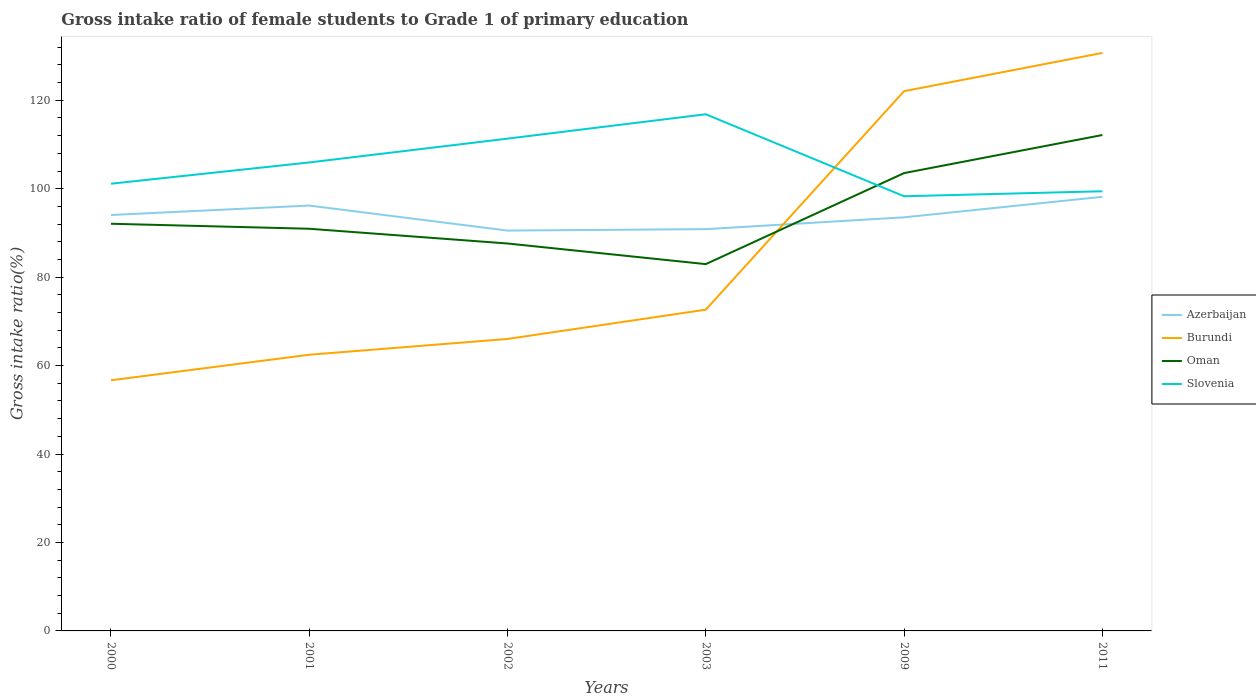Is the number of lines equal to the number of legend labels?
Keep it short and to the point. Yes. Across all years, what is the maximum gross intake ratio in Oman?
Give a very brief answer. 82.95. In which year was the gross intake ratio in Azerbaijan maximum?
Your response must be concise. 2002. What is the total gross intake ratio in Burundi in the graph?
Provide a short and direct response. -49.42. What is the difference between the highest and the second highest gross intake ratio in Oman?
Keep it short and to the point. 29.19. How many lines are there?
Your response must be concise. 4. How many years are there in the graph?
Provide a succinct answer. 6. What is the difference between two consecutive major ticks on the Y-axis?
Your response must be concise. 20. Does the graph contain any zero values?
Make the answer very short. No. How many legend labels are there?
Provide a succinct answer. 4. How are the legend labels stacked?
Your response must be concise. Vertical. What is the title of the graph?
Make the answer very short. Gross intake ratio of female students to Grade 1 of primary education. What is the label or title of the Y-axis?
Keep it short and to the point. Gross intake ratio(%). What is the Gross intake ratio(%) of Azerbaijan in 2000?
Your answer should be compact. 94.05. What is the Gross intake ratio(%) in Burundi in 2000?
Make the answer very short. 56.68. What is the Gross intake ratio(%) in Oman in 2000?
Your answer should be very brief. 92.08. What is the Gross intake ratio(%) in Slovenia in 2000?
Keep it short and to the point. 101.13. What is the Gross intake ratio(%) in Azerbaijan in 2001?
Give a very brief answer. 96.19. What is the Gross intake ratio(%) of Burundi in 2001?
Provide a succinct answer. 62.46. What is the Gross intake ratio(%) in Oman in 2001?
Give a very brief answer. 90.95. What is the Gross intake ratio(%) in Slovenia in 2001?
Keep it short and to the point. 105.94. What is the Gross intake ratio(%) of Azerbaijan in 2002?
Keep it short and to the point. 90.53. What is the Gross intake ratio(%) of Burundi in 2002?
Your answer should be compact. 66.03. What is the Gross intake ratio(%) in Oman in 2002?
Offer a terse response. 87.61. What is the Gross intake ratio(%) in Slovenia in 2002?
Provide a short and direct response. 111.33. What is the Gross intake ratio(%) of Azerbaijan in 2003?
Provide a succinct answer. 90.86. What is the Gross intake ratio(%) in Burundi in 2003?
Keep it short and to the point. 72.65. What is the Gross intake ratio(%) of Oman in 2003?
Offer a terse response. 82.95. What is the Gross intake ratio(%) of Slovenia in 2003?
Give a very brief answer. 116.84. What is the Gross intake ratio(%) in Azerbaijan in 2009?
Give a very brief answer. 93.53. What is the Gross intake ratio(%) of Burundi in 2009?
Make the answer very short. 122.06. What is the Gross intake ratio(%) in Oman in 2009?
Offer a terse response. 103.53. What is the Gross intake ratio(%) in Slovenia in 2009?
Your response must be concise. 98.3. What is the Gross intake ratio(%) of Azerbaijan in 2011?
Make the answer very short. 98.17. What is the Gross intake ratio(%) in Burundi in 2011?
Your response must be concise. 130.71. What is the Gross intake ratio(%) in Oman in 2011?
Provide a short and direct response. 112.14. What is the Gross intake ratio(%) of Slovenia in 2011?
Offer a very short reply. 99.43. Across all years, what is the maximum Gross intake ratio(%) in Azerbaijan?
Your response must be concise. 98.17. Across all years, what is the maximum Gross intake ratio(%) of Burundi?
Provide a succinct answer. 130.71. Across all years, what is the maximum Gross intake ratio(%) in Oman?
Your answer should be compact. 112.14. Across all years, what is the maximum Gross intake ratio(%) in Slovenia?
Provide a succinct answer. 116.84. Across all years, what is the minimum Gross intake ratio(%) of Azerbaijan?
Your answer should be very brief. 90.53. Across all years, what is the minimum Gross intake ratio(%) in Burundi?
Keep it short and to the point. 56.68. Across all years, what is the minimum Gross intake ratio(%) in Oman?
Provide a succinct answer. 82.95. Across all years, what is the minimum Gross intake ratio(%) of Slovenia?
Keep it short and to the point. 98.3. What is the total Gross intake ratio(%) of Azerbaijan in the graph?
Your answer should be compact. 563.34. What is the total Gross intake ratio(%) in Burundi in the graph?
Give a very brief answer. 510.57. What is the total Gross intake ratio(%) of Oman in the graph?
Make the answer very short. 569.26. What is the total Gross intake ratio(%) of Slovenia in the graph?
Make the answer very short. 632.96. What is the difference between the Gross intake ratio(%) of Azerbaijan in 2000 and that in 2001?
Provide a short and direct response. -2.14. What is the difference between the Gross intake ratio(%) in Burundi in 2000 and that in 2001?
Give a very brief answer. -5.77. What is the difference between the Gross intake ratio(%) of Oman in 2000 and that in 2001?
Give a very brief answer. 1.13. What is the difference between the Gross intake ratio(%) of Slovenia in 2000 and that in 2001?
Offer a terse response. -4.81. What is the difference between the Gross intake ratio(%) of Azerbaijan in 2000 and that in 2002?
Provide a succinct answer. 3.52. What is the difference between the Gross intake ratio(%) in Burundi in 2000 and that in 2002?
Make the answer very short. -9.34. What is the difference between the Gross intake ratio(%) in Oman in 2000 and that in 2002?
Your answer should be compact. 4.46. What is the difference between the Gross intake ratio(%) of Slovenia in 2000 and that in 2002?
Offer a terse response. -10.19. What is the difference between the Gross intake ratio(%) of Azerbaijan in 2000 and that in 2003?
Provide a succinct answer. 3.19. What is the difference between the Gross intake ratio(%) of Burundi in 2000 and that in 2003?
Ensure brevity in your answer.  -15.96. What is the difference between the Gross intake ratio(%) of Oman in 2000 and that in 2003?
Your answer should be very brief. 9.13. What is the difference between the Gross intake ratio(%) of Slovenia in 2000 and that in 2003?
Your response must be concise. -15.7. What is the difference between the Gross intake ratio(%) of Azerbaijan in 2000 and that in 2009?
Your answer should be very brief. 0.52. What is the difference between the Gross intake ratio(%) of Burundi in 2000 and that in 2009?
Keep it short and to the point. -65.38. What is the difference between the Gross intake ratio(%) of Oman in 2000 and that in 2009?
Provide a succinct answer. -11.45. What is the difference between the Gross intake ratio(%) of Slovenia in 2000 and that in 2009?
Offer a very short reply. 2.84. What is the difference between the Gross intake ratio(%) in Azerbaijan in 2000 and that in 2011?
Make the answer very short. -4.12. What is the difference between the Gross intake ratio(%) in Burundi in 2000 and that in 2011?
Keep it short and to the point. -74.02. What is the difference between the Gross intake ratio(%) in Oman in 2000 and that in 2011?
Provide a short and direct response. -20.06. What is the difference between the Gross intake ratio(%) in Slovenia in 2000 and that in 2011?
Give a very brief answer. 1.71. What is the difference between the Gross intake ratio(%) of Azerbaijan in 2001 and that in 2002?
Make the answer very short. 5.66. What is the difference between the Gross intake ratio(%) of Burundi in 2001 and that in 2002?
Your response must be concise. -3.57. What is the difference between the Gross intake ratio(%) of Oman in 2001 and that in 2002?
Offer a very short reply. 3.33. What is the difference between the Gross intake ratio(%) in Slovenia in 2001 and that in 2002?
Ensure brevity in your answer.  -5.39. What is the difference between the Gross intake ratio(%) of Azerbaijan in 2001 and that in 2003?
Keep it short and to the point. 5.33. What is the difference between the Gross intake ratio(%) in Burundi in 2001 and that in 2003?
Provide a short and direct response. -10.19. What is the difference between the Gross intake ratio(%) in Oman in 2001 and that in 2003?
Ensure brevity in your answer.  8. What is the difference between the Gross intake ratio(%) in Slovenia in 2001 and that in 2003?
Your response must be concise. -10.9. What is the difference between the Gross intake ratio(%) in Azerbaijan in 2001 and that in 2009?
Give a very brief answer. 2.66. What is the difference between the Gross intake ratio(%) in Burundi in 2001 and that in 2009?
Your answer should be very brief. -59.61. What is the difference between the Gross intake ratio(%) in Oman in 2001 and that in 2009?
Provide a succinct answer. -12.59. What is the difference between the Gross intake ratio(%) in Slovenia in 2001 and that in 2009?
Keep it short and to the point. 7.64. What is the difference between the Gross intake ratio(%) of Azerbaijan in 2001 and that in 2011?
Provide a succinct answer. -1.98. What is the difference between the Gross intake ratio(%) of Burundi in 2001 and that in 2011?
Provide a short and direct response. -68.25. What is the difference between the Gross intake ratio(%) of Oman in 2001 and that in 2011?
Your answer should be very brief. -21.2. What is the difference between the Gross intake ratio(%) in Slovenia in 2001 and that in 2011?
Ensure brevity in your answer.  6.51. What is the difference between the Gross intake ratio(%) in Azerbaijan in 2002 and that in 2003?
Ensure brevity in your answer.  -0.33. What is the difference between the Gross intake ratio(%) in Burundi in 2002 and that in 2003?
Ensure brevity in your answer.  -6.62. What is the difference between the Gross intake ratio(%) in Oman in 2002 and that in 2003?
Ensure brevity in your answer.  4.66. What is the difference between the Gross intake ratio(%) of Slovenia in 2002 and that in 2003?
Your answer should be compact. -5.51. What is the difference between the Gross intake ratio(%) in Azerbaijan in 2002 and that in 2009?
Provide a succinct answer. -3. What is the difference between the Gross intake ratio(%) in Burundi in 2002 and that in 2009?
Make the answer very short. -56.03. What is the difference between the Gross intake ratio(%) of Oman in 2002 and that in 2009?
Give a very brief answer. -15.92. What is the difference between the Gross intake ratio(%) in Slovenia in 2002 and that in 2009?
Keep it short and to the point. 13.03. What is the difference between the Gross intake ratio(%) in Azerbaijan in 2002 and that in 2011?
Make the answer very short. -7.64. What is the difference between the Gross intake ratio(%) in Burundi in 2002 and that in 2011?
Your response must be concise. -64.68. What is the difference between the Gross intake ratio(%) of Oman in 2002 and that in 2011?
Provide a short and direct response. -24.53. What is the difference between the Gross intake ratio(%) of Slovenia in 2002 and that in 2011?
Provide a succinct answer. 11.9. What is the difference between the Gross intake ratio(%) in Azerbaijan in 2003 and that in 2009?
Make the answer very short. -2.67. What is the difference between the Gross intake ratio(%) of Burundi in 2003 and that in 2009?
Offer a terse response. -49.42. What is the difference between the Gross intake ratio(%) in Oman in 2003 and that in 2009?
Make the answer very short. -20.58. What is the difference between the Gross intake ratio(%) of Slovenia in 2003 and that in 2009?
Ensure brevity in your answer.  18.54. What is the difference between the Gross intake ratio(%) in Azerbaijan in 2003 and that in 2011?
Give a very brief answer. -7.31. What is the difference between the Gross intake ratio(%) of Burundi in 2003 and that in 2011?
Your answer should be compact. -58.06. What is the difference between the Gross intake ratio(%) in Oman in 2003 and that in 2011?
Make the answer very short. -29.19. What is the difference between the Gross intake ratio(%) in Slovenia in 2003 and that in 2011?
Make the answer very short. 17.41. What is the difference between the Gross intake ratio(%) in Azerbaijan in 2009 and that in 2011?
Your answer should be compact. -4.64. What is the difference between the Gross intake ratio(%) of Burundi in 2009 and that in 2011?
Ensure brevity in your answer.  -8.64. What is the difference between the Gross intake ratio(%) of Oman in 2009 and that in 2011?
Make the answer very short. -8.61. What is the difference between the Gross intake ratio(%) in Slovenia in 2009 and that in 2011?
Offer a terse response. -1.13. What is the difference between the Gross intake ratio(%) in Azerbaijan in 2000 and the Gross intake ratio(%) in Burundi in 2001?
Your answer should be compact. 31.6. What is the difference between the Gross intake ratio(%) in Azerbaijan in 2000 and the Gross intake ratio(%) in Oman in 2001?
Your response must be concise. 3.11. What is the difference between the Gross intake ratio(%) in Azerbaijan in 2000 and the Gross intake ratio(%) in Slovenia in 2001?
Make the answer very short. -11.89. What is the difference between the Gross intake ratio(%) of Burundi in 2000 and the Gross intake ratio(%) of Oman in 2001?
Make the answer very short. -34.26. What is the difference between the Gross intake ratio(%) of Burundi in 2000 and the Gross intake ratio(%) of Slovenia in 2001?
Make the answer very short. -49.26. What is the difference between the Gross intake ratio(%) of Oman in 2000 and the Gross intake ratio(%) of Slovenia in 2001?
Provide a succinct answer. -13.86. What is the difference between the Gross intake ratio(%) of Azerbaijan in 2000 and the Gross intake ratio(%) of Burundi in 2002?
Provide a short and direct response. 28.03. What is the difference between the Gross intake ratio(%) in Azerbaijan in 2000 and the Gross intake ratio(%) in Oman in 2002?
Ensure brevity in your answer.  6.44. What is the difference between the Gross intake ratio(%) in Azerbaijan in 2000 and the Gross intake ratio(%) in Slovenia in 2002?
Give a very brief answer. -17.27. What is the difference between the Gross intake ratio(%) of Burundi in 2000 and the Gross intake ratio(%) of Oman in 2002?
Provide a succinct answer. -30.93. What is the difference between the Gross intake ratio(%) in Burundi in 2000 and the Gross intake ratio(%) in Slovenia in 2002?
Provide a short and direct response. -54.65. What is the difference between the Gross intake ratio(%) of Oman in 2000 and the Gross intake ratio(%) of Slovenia in 2002?
Keep it short and to the point. -19.25. What is the difference between the Gross intake ratio(%) in Azerbaijan in 2000 and the Gross intake ratio(%) in Burundi in 2003?
Your answer should be compact. 21.41. What is the difference between the Gross intake ratio(%) of Azerbaijan in 2000 and the Gross intake ratio(%) of Oman in 2003?
Provide a short and direct response. 11.1. What is the difference between the Gross intake ratio(%) of Azerbaijan in 2000 and the Gross intake ratio(%) of Slovenia in 2003?
Your answer should be very brief. -22.78. What is the difference between the Gross intake ratio(%) in Burundi in 2000 and the Gross intake ratio(%) in Oman in 2003?
Offer a very short reply. -26.27. What is the difference between the Gross intake ratio(%) in Burundi in 2000 and the Gross intake ratio(%) in Slovenia in 2003?
Your response must be concise. -60.16. What is the difference between the Gross intake ratio(%) in Oman in 2000 and the Gross intake ratio(%) in Slovenia in 2003?
Make the answer very short. -24.76. What is the difference between the Gross intake ratio(%) in Azerbaijan in 2000 and the Gross intake ratio(%) in Burundi in 2009?
Offer a terse response. -28.01. What is the difference between the Gross intake ratio(%) in Azerbaijan in 2000 and the Gross intake ratio(%) in Oman in 2009?
Provide a succinct answer. -9.48. What is the difference between the Gross intake ratio(%) of Azerbaijan in 2000 and the Gross intake ratio(%) of Slovenia in 2009?
Your answer should be compact. -4.24. What is the difference between the Gross intake ratio(%) of Burundi in 2000 and the Gross intake ratio(%) of Oman in 2009?
Keep it short and to the point. -46.85. What is the difference between the Gross intake ratio(%) in Burundi in 2000 and the Gross intake ratio(%) in Slovenia in 2009?
Ensure brevity in your answer.  -41.61. What is the difference between the Gross intake ratio(%) in Oman in 2000 and the Gross intake ratio(%) in Slovenia in 2009?
Keep it short and to the point. -6.22. What is the difference between the Gross intake ratio(%) in Azerbaijan in 2000 and the Gross intake ratio(%) in Burundi in 2011?
Your response must be concise. -36.65. What is the difference between the Gross intake ratio(%) in Azerbaijan in 2000 and the Gross intake ratio(%) in Oman in 2011?
Offer a terse response. -18.09. What is the difference between the Gross intake ratio(%) of Azerbaijan in 2000 and the Gross intake ratio(%) of Slovenia in 2011?
Keep it short and to the point. -5.37. What is the difference between the Gross intake ratio(%) of Burundi in 2000 and the Gross intake ratio(%) of Oman in 2011?
Provide a short and direct response. -55.46. What is the difference between the Gross intake ratio(%) of Burundi in 2000 and the Gross intake ratio(%) of Slovenia in 2011?
Keep it short and to the point. -42.74. What is the difference between the Gross intake ratio(%) of Oman in 2000 and the Gross intake ratio(%) of Slovenia in 2011?
Your answer should be very brief. -7.35. What is the difference between the Gross intake ratio(%) of Azerbaijan in 2001 and the Gross intake ratio(%) of Burundi in 2002?
Your answer should be compact. 30.17. What is the difference between the Gross intake ratio(%) in Azerbaijan in 2001 and the Gross intake ratio(%) in Oman in 2002?
Offer a very short reply. 8.58. What is the difference between the Gross intake ratio(%) in Azerbaijan in 2001 and the Gross intake ratio(%) in Slovenia in 2002?
Ensure brevity in your answer.  -15.13. What is the difference between the Gross intake ratio(%) in Burundi in 2001 and the Gross intake ratio(%) in Oman in 2002?
Offer a terse response. -25.16. What is the difference between the Gross intake ratio(%) in Burundi in 2001 and the Gross intake ratio(%) in Slovenia in 2002?
Your response must be concise. -48.87. What is the difference between the Gross intake ratio(%) in Oman in 2001 and the Gross intake ratio(%) in Slovenia in 2002?
Your answer should be compact. -20.38. What is the difference between the Gross intake ratio(%) of Azerbaijan in 2001 and the Gross intake ratio(%) of Burundi in 2003?
Offer a terse response. 23.55. What is the difference between the Gross intake ratio(%) of Azerbaijan in 2001 and the Gross intake ratio(%) of Oman in 2003?
Offer a very short reply. 13.24. What is the difference between the Gross intake ratio(%) of Azerbaijan in 2001 and the Gross intake ratio(%) of Slovenia in 2003?
Give a very brief answer. -20.64. What is the difference between the Gross intake ratio(%) in Burundi in 2001 and the Gross intake ratio(%) in Oman in 2003?
Offer a very short reply. -20.5. What is the difference between the Gross intake ratio(%) of Burundi in 2001 and the Gross intake ratio(%) of Slovenia in 2003?
Ensure brevity in your answer.  -54.38. What is the difference between the Gross intake ratio(%) of Oman in 2001 and the Gross intake ratio(%) of Slovenia in 2003?
Provide a short and direct response. -25.89. What is the difference between the Gross intake ratio(%) in Azerbaijan in 2001 and the Gross intake ratio(%) in Burundi in 2009?
Your response must be concise. -25.87. What is the difference between the Gross intake ratio(%) of Azerbaijan in 2001 and the Gross intake ratio(%) of Oman in 2009?
Your response must be concise. -7.34. What is the difference between the Gross intake ratio(%) in Azerbaijan in 2001 and the Gross intake ratio(%) in Slovenia in 2009?
Offer a terse response. -2.1. What is the difference between the Gross intake ratio(%) of Burundi in 2001 and the Gross intake ratio(%) of Oman in 2009?
Offer a terse response. -41.08. What is the difference between the Gross intake ratio(%) of Burundi in 2001 and the Gross intake ratio(%) of Slovenia in 2009?
Provide a short and direct response. -35.84. What is the difference between the Gross intake ratio(%) of Oman in 2001 and the Gross intake ratio(%) of Slovenia in 2009?
Make the answer very short. -7.35. What is the difference between the Gross intake ratio(%) in Azerbaijan in 2001 and the Gross intake ratio(%) in Burundi in 2011?
Provide a short and direct response. -34.51. What is the difference between the Gross intake ratio(%) in Azerbaijan in 2001 and the Gross intake ratio(%) in Oman in 2011?
Your answer should be compact. -15.95. What is the difference between the Gross intake ratio(%) in Azerbaijan in 2001 and the Gross intake ratio(%) in Slovenia in 2011?
Offer a terse response. -3.23. What is the difference between the Gross intake ratio(%) in Burundi in 2001 and the Gross intake ratio(%) in Oman in 2011?
Your response must be concise. -49.69. What is the difference between the Gross intake ratio(%) of Burundi in 2001 and the Gross intake ratio(%) of Slovenia in 2011?
Your response must be concise. -36.97. What is the difference between the Gross intake ratio(%) of Oman in 2001 and the Gross intake ratio(%) of Slovenia in 2011?
Offer a terse response. -8.48. What is the difference between the Gross intake ratio(%) of Azerbaijan in 2002 and the Gross intake ratio(%) of Burundi in 2003?
Make the answer very short. 17.89. What is the difference between the Gross intake ratio(%) of Azerbaijan in 2002 and the Gross intake ratio(%) of Oman in 2003?
Your answer should be very brief. 7.58. What is the difference between the Gross intake ratio(%) of Azerbaijan in 2002 and the Gross intake ratio(%) of Slovenia in 2003?
Keep it short and to the point. -26.3. What is the difference between the Gross intake ratio(%) of Burundi in 2002 and the Gross intake ratio(%) of Oman in 2003?
Provide a short and direct response. -16.92. What is the difference between the Gross intake ratio(%) of Burundi in 2002 and the Gross intake ratio(%) of Slovenia in 2003?
Offer a terse response. -50.81. What is the difference between the Gross intake ratio(%) in Oman in 2002 and the Gross intake ratio(%) in Slovenia in 2003?
Keep it short and to the point. -29.22. What is the difference between the Gross intake ratio(%) of Azerbaijan in 2002 and the Gross intake ratio(%) of Burundi in 2009?
Offer a terse response. -31.53. What is the difference between the Gross intake ratio(%) of Azerbaijan in 2002 and the Gross intake ratio(%) of Oman in 2009?
Provide a succinct answer. -13. What is the difference between the Gross intake ratio(%) of Azerbaijan in 2002 and the Gross intake ratio(%) of Slovenia in 2009?
Make the answer very short. -7.76. What is the difference between the Gross intake ratio(%) of Burundi in 2002 and the Gross intake ratio(%) of Oman in 2009?
Give a very brief answer. -37.51. What is the difference between the Gross intake ratio(%) of Burundi in 2002 and the Gross intake ratio(%) of Slovenia in 2009?
Give a very brief answer. -32.27. What is the difference between the Gross intake ratio(%) of Oman in 2002 and the Gross intake ratio(%) of Slovenia in 2009?
Your response must be concise. -10.68. What is the difference between the Gross intake ratio(%) in Azerbaijan in 2002 and the Gross intake ratio(%) in Burundi in 2011?
Offer a very short reply. -40.17. What is the difference between the Gross intake ratio(%) of Azerbaijan in 2002 and the Gross intake ratio(%) of Oman in 2011?
Give a very brief answer. -21.61. What is the difference between the Gross intake ratio(%) of Azerbaijan in 2002 and the Gross intake ratio(%) of Slovenia in 2011?
Make the answer very short. -8.89. What is the difference between the Gross intake ratio(%) in Burundi in 2002 and the Gross intake ratio(%) in Oman in 2011?
Make the answer very short. -46.12. What is the difference between the Gross intake ratio(%) of Burundi in 2002 and the Gross intake ratio(%) of Slovenia in 2011?
Make the answer very short. -33.4. What is the difference between the Gross intake ratio(%) in Oman in 2002 and the Gross intake ratio(%) in Slovenia in 2011?
Your answer should be compact. -11.81. What is the difference between the Gross intake ratio(%) in Azerbaijan in 2003 and the Gross intake ratio(%) in Burundi in 2009?
Provide a succinct answer. -31.2. What is the difference between the Gross intake ratio(%) of Azerbaijan in 2003 and the Gross intake ratio(%) of Oman in 2009?
Offer a very short reply. -12.67. What is the difference between the Gross intake ratio(%) in Azerbaijan in 2003 and the Gross intake ratio(%) in Slovenia in 2009?
Offer a very short reply. -7.44. What is the difference between the Gross intake ratio(%) in Burundi in 2003 and the Gross intake ratio(%) in Oman in 2009?
Provide a short and direct response. -30.89. What is the difference between the Gross intake ratio(%) in Burundi in 2003 and the Gross intake ratio(%) in Slovenia in 2009?
Keep it short and to the point. -25.65. What is the difference between the Gross intake ratio(%) of Oman in 2003 and the Gross intake ratio(%) of Slovenia in 2009?
Your response must be concise. -15.35. What is the difference between the Gross intake ratio(%) of Azerbaijan in 2003 and the Gross intake ratio(%) of Burundi in 2011?
Your answer should be compact. -39.85. What is the difference between the Gross intake ratio(%) in Azerbaijan in 2003 and the Gross intake ratio(%) in Oman in 2011?
Offer a terse response. -21.28. What is the difference between the Gross intake ratio(%) in Azerbaijan in 2003 and the Gross intake ratio(%) in Slovenia in 2011?
Offer a very short reply. -8.57. What is the difference between the Gross intake ratio(%) of Burundi in 2003 and the Gross intake ratio(%) of Oman in 2011?
Provide a succinct answer. -39.5. What is the difference between the Gross intake ratio(%) in Burundi in 2003 and the Gross intake ratio(%) in Slovenia in 2011?
Offer a terse response. -26.78. What is the difference between the Gross intake ratio(%) in Oman in 2003 and the Gross intake ratio(%) in Slovenia in 2011?
Your answer should be compact. -16.47. What is the difference between the Gross intake ratio(%) in Azerbaijan in 2009 and the Gross intake ratio(%) in Burundi in 2011?
Your answer should be very brief. -37.18. What is the difference between the Gross intake ratio(%) of Azerbaijan in 2009 and the Gross intake ratio(%) of Oman in 2011?
Provide a succinct answer. -18.61. What is the difference between the Gross intake ratio(%) in Azerbaijan in 2009 and the Gross intake ratio(%) in Slovenia in 2011?
Make the answer very short. -5.9. What is the difference between the Gross intake ratio(%) in Burundi in 2009 and the Gross intake ratio(%) in Oman in 2011?
Your answer should be compact. 9.92. What is the difference between the Gross intake ratio(%) in Burundi in 2009 and the Gross intake ratio(%) in Slovenia in 2011?
Offer a very short reply. 22.64. What is the difference between the Gross intake ratio(%) in Oman in 2009 and the Gross intake ratio(%) in Slovenia in 2011?
Your response must be concise. 4.11. What is the average Gross intake ratio(%) in Azerbaijan per year?
Your answer should be very brief. 93.89. What is the average Gross intake ratio(%) of Burundi per year?
Offer a very short reply. 85.1. What is the average Gross intake ratio(%) of Oman per year?
Offer a very short reply. 94.88. What is the average Gross intake ratio(%) in Slovenia per year?
Provide a short and direct response. 105.49. In the year 2000, what is the difference between the Gross intake ratio(%) in Azerbaijan and Gross intake ratio(%) in Burundi?
Keep it short and to the point. 37.37. In the year 2000, what is the difference between the Gross intake ratio(%) of Azerbaijan and Gross intake ratio(%) of Oman?
Make the answer very short. 1.98. In the year 2000, what is the difference between the Gross intake ratio(%) of Azerbaijan and Gross intake ratio(%) of Slovenia?
Make the answer very short. -7.08. In the year 2000, what is the difference between the Gross intake ratio(%) of Burundi and Gross intake ratio(%) of Oman?
Your answer should be compact. -35.4. In the year 2000, what is the difference between the Gross intake ratio(%) of Burundi and Gross intake ratio(%) of Slovenia?
Your answer should be compact. -44.45. In the year 2000, what is the difference between the Gross intake ratio(%) in Oman and Gross intake ratio(%) in Slovenia?
Your response must be concise. -9.05. In the year 2001, what is the difference between the Gross intake ratio(%) of Azerbaijan and Gross intake ratio(%) of Burundi?
Keep it short and to the point. 33.74. In the year 2001, what is the difference between the Gross intake ratio(%) in Azerbaijan and Gross intake ratio(%) in Oman?
Make the answer very short. 5.25. In the year 2001, what is the difference between the Gross intake ratio(%) of Azerbaijan and Gross intake ratio(%) of Slovenia?
Keep it short and to the point. -9.75. In the year 2001, what is the difference between the Gross intake ratio(%) in Burundi and Gross intake ratio(%) in Oman?
Offer a very short reply. -28.49. In the year 2001, what is the difference between the Gross intake ratio(%) in Burundi and Gross intake ratio(%) in Slovenia?
Give a very brief answer. -43.48. In the year 2001, what is the difference between the Gross intake ratio(%) in Oman and Gross intake ratio(%) in Slovenia?
Your answer should be compact. -14.99. In the year 2002, what is the difference between the Gross intake ratio(%) of Azerbaijan and Gross intake ratio(%) of Burundi?
Offer a terse response. 24.51. In the year 2002, what is the difference between the Gross intake ratio(%) of Azerbaijan and Gross intake ratio(%) of Oman?
Give a very brief answer. 2.92. In the year 2002, what is the difference between the Gross intake ratio(%) of Azerbaijan and Gross intake ratio(%) of Slovenia?
Give a very brief answer. -20.79. In the year 2002, what is the difference between the Gross intake ratio(%) of Burundi and Gross intake ratio(%) of Oman?
Your answer should be very brief. -21.59. In the year 2002, what is the difference between the Gross intake ratio(%) of Burundi and Gross intake ratio(%) of Slovenia?
Ensure brevity in your answer.  -45.3. In the year 2002, what is the difference between the Gross intake ratio(%) of Oman and Gross intake ratio(%) of Slovenia?
Your response must be concise. -23.71. In the year 2003, what is the difference between the Gross intake ratio(%) of Azerbaijan and Gross intake ratio(%) of Burundi?
Offer a terse response. 18.21. In the year 2003, what is the difference between the Gross intake ratio(%) of Azerbaijan and Gross intake ratio(%) of Oman?
Offer a terse response. 7.91. In the year 2003, what is the difference between the Gross intake ratio(%) of Azerbaijan and Gross intake ratio(%) of Slovenia?
Your answer should be compact. -25.98. In the year 2003, what is the difference between the Gross intake ratio(%) of Burundi and Gross intake ratio(%) of Oman?
Your answer should be compact. -10.31. In the year 2003, what is the difference between the Gross intake ratio(%) in Burundi and Gross intake ratio(%) in Slovenia?
Your answer should be very brief. -44.19. In the year 2003, what is the difference between the Gross intake ratio(%) of Oman and Gross intake ratio(%) of Slovenia?
Give a very brief answer. -33.89. In the year 2009, what is the difference between the Gross intake ratio(%) of Azerbaijan and Gross intake ratio(%) of Burundi?
Offer a terse response. -28.53. In the year 2009, what is the difference between the Gross intake ratio(%) in Azerbaijan and Gross intake ratio(%) in Oman?
Make the answer very short. -10. In the year 2009, what is the difference between the Gross intake ratio(%) of Azerbaijan and Gross intake ratio(%) of Slovenia?
Give a very brief answer. -4.77. In the year 2009, what is the difference between the Gross intake ratio(%) in Burundi and Gross intake ratio(%) in Oman?
Offer a terse response. 18.53. In the year 2009, what is the difference between the Gross intake ratio(%) of Burundi and Gross intake ratio(%) of Slovenia?
Provide a short and direct response. 23.76. In the year 2009, what is the difference between the Gross intake ratio(%) of Oman and Gross intake ratio(%) of Slovenia?
Your answer should be very brief. 5.24. In the year 2011, what is the difference between the Gross intake ratio(%) in Azerbaijan and Gross intake ratio(%) in Burundi?
Give a very brief answer. -32.53. In the year 2011, what is the difference between the Gross intake ratio(%) of Azerbaijan and Gross intake ratio(%) of Oman?
Keep it short and to the point. -13.97. In the year 2011, what is the difference between the Gross intake ratio(%) of Azerbaijan and Gross intake ratio(%) of Slovenia?
Ensure brevity in your answer.  -1.25. In the year 2011, what is the difference between the Gross intake ratio(%) of Burundi and Gross intake ratio(%) of Oman?
Your answer should be compact. 18.56. In the year 2011, what is the difference between the Gross intake ratio(%) in Burundi and Gross intake ratio(%) in Slovenia?
Give a very brief answer. 31.28. In the year 2011, what is the difference between the Gross intake ratio(%) in Oman and Gross intake ratio(%) in Slovenia?
Your answer should be very brief. 12.72. What is the ratio of the Gross intake ratio(%) of Azerbaijan in 2000 to that in 2001?
Your answer should be compact. 0.98. What is the ratio of the Gross intake ratio(%) of Burundi in 2000 to that in 2001?
Make the answer very short. 0.91. What is the ratio of the Gross intake ratio(%) of Oman in 2000 to that in 2001?
Ensure brevity in your answer.  1.01. What is the ratio of the Gross intake ratio(%) in Slovenia in 2000 to that in 2001?
Your answer should be very brief. 0.95. What is the ratio of the Gross intake ratio(%) in Azerbaijan in 2000 to that in 2002?
Offer a very short reply. 1.04. What is the ratio of the Gross intake ratio(%) of Burundi in 2000 to that in 2002?
Ensure brevity in your answer.  0.86. What is the ratio of the Gross intake ratio(%) of Oman in 2000 to that in 2002?
Ensure brevity in your answer.  1.05. What is the ratio of the Gross intake ratio(%) in Slovenia in 2000 to that in 2002?
Offer a very short reply. 0.91. What is the ratio of the Gross intake ratio(%) of Azerbaijan in 2000 to that in 2003?
Keep it short and to the point. 1.04. What is the ratio of the Gross intake ratio(%) of Burundi in 2000 to that in 2003?
Provide a succinct answer. 0.78. What is the ratio of the Gross intake ratio(%) in Oman in 2000 to that in 2003?
Offer a terse response. 1.11. What is the ratio of the Gross intake ratio(%) in Slovenia in 2000 to that in 2003?
Provide a short and direct response. 0.87. What is the ratio of the Gross intake ratio(%) in Azerbaijan in 2000 to that in 2009?
Ensure brevity in your answer.  1.01. What is the ratio of the Gross intake ratio(%) of Burundi in 2000 to that in 2009?
Keep it short and to the point. 0.46. What is the ratio of the Gross intake ratio(%) of Oman in 2000 to that in 2009?
Your answer should be compact. 0.89. What is the ratio of the Gross intake ratio(%) of Slovenia in 2000 to that in 2009?
Provide a succinct answer. 1.03. What is the ratio of the Gross intake ratio(%) of Azerbaijan in 2000 to that in 2011?
Give a very brief answer. 0.96. What is the ratio of the Gross intake ratio(%) in Burundi in 2000 to that in 2011?
Your answer should be compact. 0.43. What is the ratio of the Gross intake ratio(%) of Oman in 2000 to that in 2011?
Provide a short and direct response. 0.82. What is the ratio of the Gross intake ratio(%) in Slovenia in 2000 to that in 2011?
Give a very brief answer. 1.02. What is the ratio of the Gross intake ratio(%) in Burundi in 2001 to that in 2002?
Provide a succinct answer. 0.95. What is the ratio of the Gross intake ratio(%) of Oman in 2001 to that in 2002?
Keep it short and to the point. 1.04. What is the ratio of the Gross intake ratio(%) in Slovenia in 2001 to that in 2002?
Give a very brief answer. 0.95. What is the ratio of the Gross intake ratio(%) of Azerbaijan in 2001 to that in 2003?
Offer a terse response. 1.06. What is the ratio of the Gross intake ratio(%) of Burundi in 2001 to that in 2003?
Ensure brevity in your answer.  0.86. What is the ratio of the Gross intake ratio(%) in Oman in 2001 to that in 2003?
Ensure brevity in your answer.  1.1. What is the ratio of the Gross intake ratio(%) of Slovenia in 2001 to that in 2003?
Make the answer very short. 0.91. What is the ratio of the Gross intake ratio(%) in Azerbaijan in 2001 to that in 2009?
Offer a terse response. 1.03. What is the ratio of the Gross intake ratio(%) of Burundi in 2001 to that in 2009?
Give a very brief answer. 0.51. What is the ratio of the Gross intake ratio(%) in Oman in 2001 to that in 2009?
Make the answer very short. 0.88. What is the ratio of the Gross intake ratio(%) in Slovenia in 2001 to that in 2009?
Your response must be concise. 1.08. What is the ratio of the Gross intake ratio(%) of Azerbaijan in 2001 to that in 2011?
Your answer should be compact. 0.98. What is the ratio of the Gross intake ratio(%) of Burundi in 2001 to that in 2011?
Provide a short and direct response. 0.48. What is the ratio of the Gross intake ratio(%) of Oman in 2001 to that in 2011?
Give a very brief answer. 0.81. What is the ratio of the Gross intake ratio(%) of Slovenia in 2001 to that in 2011?
Provide a succinct answer. 1.07. What is the ratio of the Gross intake ratio(%) of Azerbaijan in 2002 to that in 2003?
Keep it short and to the point. 1. What is the ratio of the Gross intake ratio(%) in Burundi in 2002 to that in 2003?
Offer a terse response. 0.91. What is the ratio of the Gross intake ratio(%) in Oman in 2002 to that in 2003?
Your answer should be compact. 1.06. What is the ratio of the Gross intake ratio(%) of Slovenia in 2002 to that in 2003?
Provide a short and direct response. 0.95. What is the ratio of the Gross intake ratio(%) in Burundi in 2002 to that in 2009?
Make the answer very short. 0.54. What is the ratio of the Gross intake ratio(%) of Oman in 2002 to that in 2009?
Your response must be concise. 0.85. What is the ratio of the Gross intake ratio(%) of Slovenia in 2002 to that in 2009?
Offer a terse response. 1.13. What is the ratio of the Gross intake ratio(%) in Azerbaijan in 2002 to that in 2011?
Give a very brief answer. 0.92. What is the ratio of the Gross intake ratio(%) of Burundi in 2002 to that in 2011?
Provide a short and direct response. 0.51. What is the ratio of the Gross intake ratio(%) of Oman in 2002 to that in 2011?
Keep it short and to the point. 0.78. What is the ratio of the Gross intake ratio(%) in Slovenia in 2002 to that in 2011?
Your answer should be compact. 1.12. What is the ratio of the Gross intake ratio(%) of Azerbaijan in 2003 to that in 2009?
Ensure brevity in your answer.  0.97. What is the ratio of the Gross intake ratio(%) in Burundi in 2003 to that in 2009?
Your response must be concise. 0.6. What is the ratio of the Gross intake ratio(%) in Oman in 2003 to that in 2009?
Your response must be concise. 0.8. What is the ratio of the Gross intake ratio(%) in Slovenia in 2003 to that in 2009?
Provide a succinct answer. 1.19. What is the ratio of the Gross intake ratio(%) in Azerbaijan in 2003 to that in 2011?
Give a very brief answer. 0.93. What is the ratio of the Gross intake ratio(%) in Burundi in 2003 to that in 2011?
Offer a terse response. 0.56. What is the ratio of the Gross intake ratio(%) in Oman in 2003 to that in 2011?
Your response must be concise. 0.74. What is the ratio of the Gross intake ratio(%) of Slovenia in 2003 to that in 2011?
Make the answer very short. 1.18. What is the ratio of the Gross intake ratio(%) in Azerbaijan in 2009 to that in 2011?
Your answer should be very brief. 0.95. What is the ratio of the Gross intake ratio(%) in Burundi in 2009 to that in 2011?
Provide a short and direct response. 0.93. What is the ratio of the Gross intake ratio(%) of Oman in 2009 to that in 2011?
Make the answer very short. 0.92. What is the ratio of the Gross intake ratio(%) in Slovenia in 2009 to that in 2011?
Make the answer very short. 0.99. What is the difference between the highest and the second highest Gross intake ratio(%) of Azerbaijan?
Your answer should be very brief. 1.98. What is the difference between the highest and the second highest Gross intake ratio(%) in Burundi?
Make the answer very short. 8.64. What is the difference between the highest and the second highest Gross intake ratio(%) in Oman?
Keep it short and to the point. 8.61. What is the difference between the highest and the second highest Gross intake ratio(%) of Slovenia?
Make the answer very short. 5.51. What is the difference between the highest and the lowest Gross intake ratio(%) of Azerbaijan?
Your answer should be compact. 7.64. What is the difference between the highest and the lowest Gross intake ratio(%) in Burundi?
Offer a very short reply. 74.02. What is the difference between the highest and the lowest Gross intake ratio(%) of Oman?
Offer a very short reply. 29.19. What is the difference between the highest and the lowest Gross intake ratio(%) of Slovenia?
Provide a succinct answer. 18.54. 